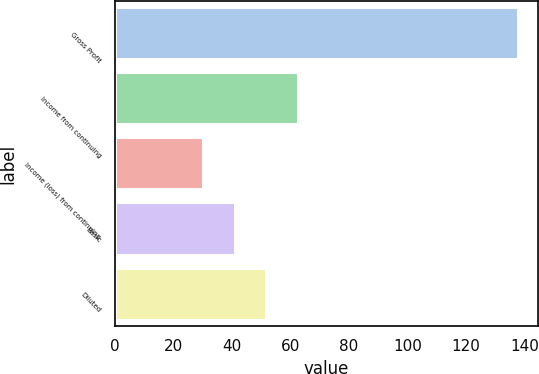Convert chart to OTSL. <chart><loc_0><loc_0><loc_500><loc_500><bar_chart><fcel>Gross Profit<fcel>Income from continuing<fcel>Income (loss) from continuing<fcel>Basic<fcel>Diluted<nl><fcel>137.8<fcel>62.41<fcel>30.1<fcel>40.87<fcel>51.64<nl></chart> 